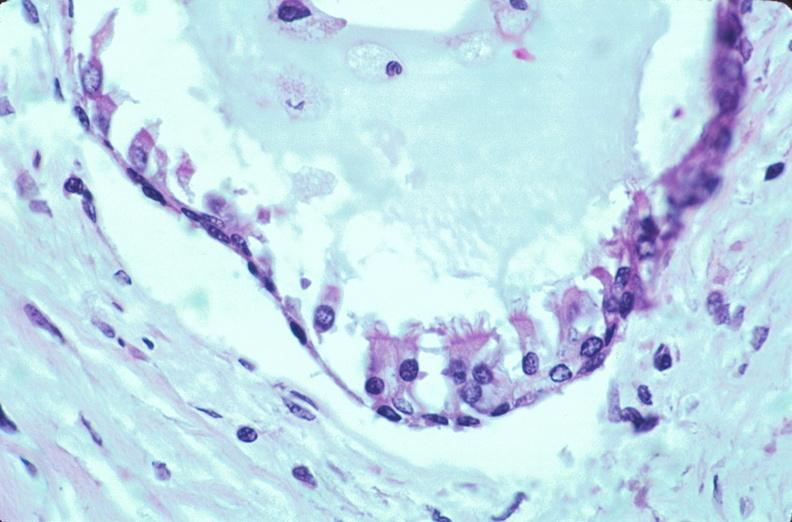does this image show pharyngeal pouch remnant, incidental finding in 32 yo man?
Answer the question using a single word or phrase. Yes 